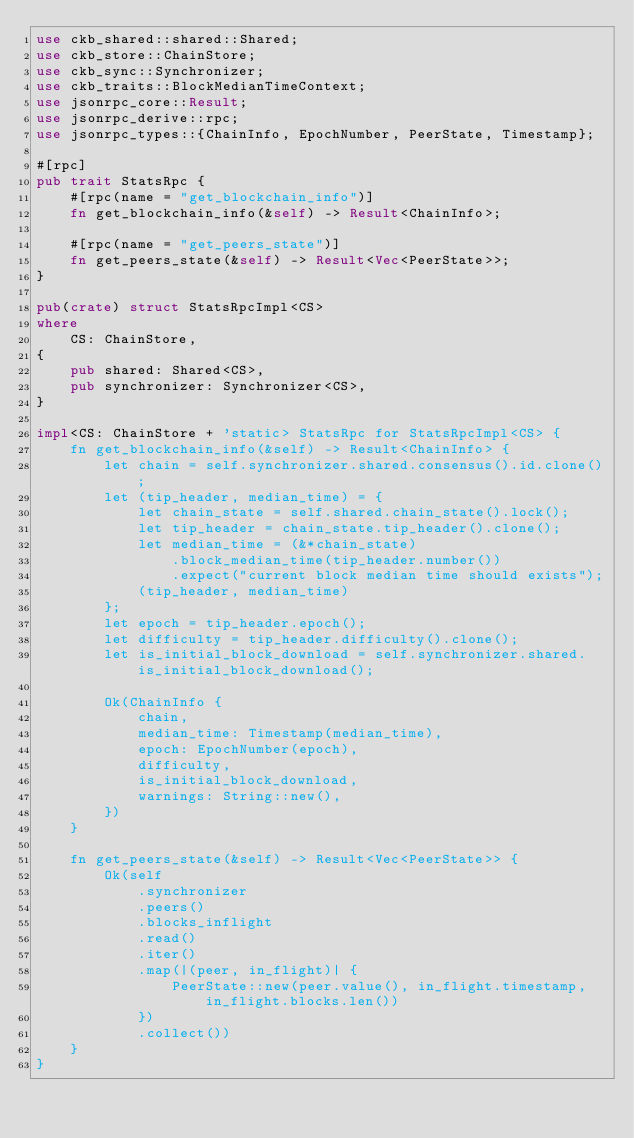<code> <loc_0><loc_0><loc_500><loc_500><_Rust_>use ckb_shared::shared::Shared;
use ckb_store::ChainStore;
use ckb_sync::Synchronizer;
use ckb_traits::BlockMedianTimeContext;
use jsonrpc_core::Result;
use jsonrpc_derive::rpc;
use jsonrpc_types::{ChainInfo, EpochNumber, PeerState, Timestamp};

#[rpc]
pub trait StatsRpc {
    #[rpc(name = "get_blockchain_info")]
    fn get_blockchain_info(&self) -> Result<ChainInfo>;

    #[rpc(name = "get_peers_state")]
    fn get_peers_state(&self) -> Result<Vec<PeerState>>;
}

pub(crate) struct StatsRpcImpl<CS>
where
    CS: ChainStore,
{
    pub shared: Shared<CS>,
    pub synchronizer: Synchronizer<CS>,
}

impl<CS: ChainStore + 'static> StatsRpc for StatsRpcImpl<CS> {
    fn get_blockchain_info(&self) -> Result<ChainInfo> {
        let chain = self.synchronizer.shared.consensus().id.clone();
        let (tip_header, median_time) = {
            let chain_state = self.shared.chain_state().lock();
            let tip_header = chain_state.tip_header().clone();
            let median_time = (&*chain_state)
                .block_median_time(tip_header.number())
                .expect("current block median time should exists");
            (tip_header, median_time)
        };
        let epoch = tip_header.epoch();
        let difficulty = tip_header.difficulty().clone();
        let is_initial_block_download = self.synchronizer.shared.is_initial_block_download();

        Ok(ChainInfo {
            chain,
            median_time: Timestamp(median_time),
            epoch: EpochNumber(epoch),
            difficulty,
            is_initial_block_download,
            warnings: String::new(),
        })
    }

    fn get_peers_state(&self) -> Result<Vec<PeerState>> {
        Ok(self
            .synchronizer
            .peers()
            .blocks_inflight
            .read()
            .iter()
            .map(|(peer, in_flight)| {
                PeerState::new(peer.value(), in_flight.timestamp, in_flight.blocks.len())
            })
            .collect())
    }
}
</code> 